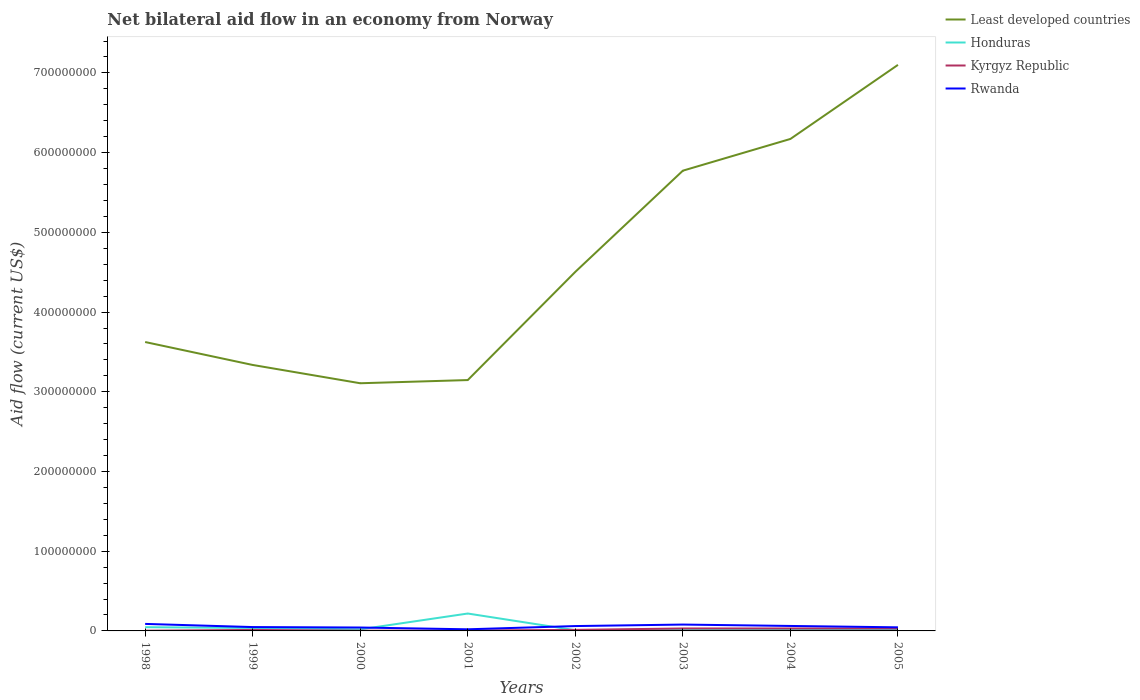Does the line corresponding to Kyrgyz Republic intersect with the line corresponding to Rwanda?
Make the answer very short. No. Is the number of lines equal to the number of legend labels?
Offer a very short reply. Yes. Across all years, what is the maximum net bilateral aid flow in Honduras?
Make the answer very short. 8.80e+05. In which year was the net bilateral aid flow in Honduras maximum?
Your answer should be very brief. 2002. What is the total net bilateral aid flow in Least developed countries in the graph?
Offer a very short reply. -4.00e+06. What is the difference between the highest and the second highest net bilateral aid flow in Honduras?
Offer a terse response. 2.10e+07. What is the difference between the highest and the lowest net bilateral aid flow in Honduras?
Make the answer very short. 1. How many lines are there?
Give a very brief answer. 4. Does the graph contain grids?
Offer a very short reply. No. Where does the legend appear in the graph?
Offer a terse response. Top right. What is the title of the graph?
Offer a terse response. Net bilateral aid flow in an economy from Norway. Does "Mexico" appear as one of the legend labels in the graph?
Your answer should be compact. No. What is the Aid flow (current US$) in Least developed countries in 1998?
Offer a terse response. 3.62e+08. What is the Aid flow (current US$) in Honduras in 1998?
Offer a very short reply. 4.66e+06. What is the Aid flow (current US$) of Kyrgyz Republic in 1998?
Offer a terse response. 3.00e+05. What is the Aid flow (current US$) in Rwanda in 1998?
Your answer should be very brief. 8.80e+06. What is the Aid flow (current US$) in Least developed countries in 1999?
Your answer should be very brief. 3.34e+08. What is the Aid flow (current US$) in Honduras in 1999?
Keep it short and to the point. 3.70e+06. What is the Aid flow (current US$) of Kyrgyz Republic in 1999?
Ensure brevity in your answer.  1.23e+06. What is the Aid flow (current US$) of Rwanda in 1999?
Your answer should be very brief. 4.84e+06. What is the Aid flow (current US$) of Least developed countries in 2000?
Offer a terse response. 3.11e+08. What is the Aid flow (current US$) of Honduras in 2000?
Your response must be concise. 1.97e+06. What is the Aid flow (current US$) in Kyrgyz Republic in 2000?
Offer a very short reply. 2.90e+05. What is the Aid flow (current US$) in Rwanda in 2000?
Your answer should be compact. 4.27e+06. What is the Aid flow (current US$) of Least developed countries in 2001?
Keep it short and to the point. 3.15e+08. What is the Aid flow (current US$) in Honduras in 2001?
Provide a succinct answer. 2.18e+07. What is the Aid flow (current US$) of Kyrgyz Republic in 2001?
Offer a very short reply. 5.10e+05. What is the Aid flow (current US$) of Rwanda in 2001?
Your answer should be very brief. 2.03e+06. What is the Aid flow (current US$) in Least developed countries in 2002?
Keep it short and to the point. 4.50e+08. What is the Aid flow (current US$) of Honduras in 2002?
Make the answer very short. 8.80e+05. What is the Aid flow (current US$) in Kyrgyz Republic in 2002?
Make the answer very short. 1.31e+06. What is the Aid flow (current US$) in Rwanda in 2002?
Provide a succinct answer. 6.09e+06. What is the Aid flow (current US$) of Least developed countries in 2003?
Your answer should be very brief. 5.77e+08. What is the Aid flow (current US$) in Honduras in 2003?
Your response must be concise. 1.63e+06. What is the Aid flow (current US$) in Kyrgyz Republic in 2003?
Ensure brevity in your answer.  3.07e+06. What is the Aid flow (current US$) in Rwanda in 2003?
Provide a short and direct response. 7.97e+06. What is the Aid flow (current US$) of Least developed countries in 2004?
Your answer should be very brief. 6.17e+08. What is the Aid flow (current US$) of Honduras in 2004?
Offer a very short reply. 1.84e+06. What is the Aid flow (current US$) of Kyrgyz Republic in 2004?
Make the answer very short. 3.07e+06. What is the Aid flow (current US$) of Rwanda in 2004?
Provide a succinct answer. 6.24e+06. What is the Aid flow (current US$) in Least developed countries in 2005?
Your answer should be compact. 7.10e+08. What is the Aid flow (current US$) in Honduras in 2005?
Provide a short and direct response. 1.69e+06. What is the Aid flow (current US$) in Kyrgyz Republic in 2005?
Offer a very short reply. 3.08e+06. What is the Aid flow (current US$) in Rwanda in 2005?
Provide a succinct answer. 4.50e+06. Across all years, what is the maximum Aid flow (current US$) in Least developed countries?
Your response must be concise. 7.10e+08. Across all years, what is the maximum Aid flow (current US$) in Honduras?
Provide a succinct answer. 2.18e+07. Across all years, what is the maximum Aid flow (current US$) in Kyrgyz Republic?
Ensure brevity in your answer.  3.08e+06. Across all years, what is the maximum Aid flow (current US$) of Rwanda?
Offer a very short reply. 8.80e+06. Across all years, what is the minimum Aid flow (current US$) in Least developed countries?
Provide a succinct answer. 3.11e+08. Across all years, what is the minimum Aid flow (current US$) of Honduras?
Give a very brief answer. 8.80e+05. Across all years, what is the minimum Aid flow (current US$) in Kyrgyz Republic?
Give a very brief answer. 2.90e+05. Across all years, what is the minimum Aid flow (current US$) in Rwanda?
Keep it short and to the point. 2.03e+06. What is the total Aid flow (current US$) in Least developed countries in the graph?
Offer a terse response. 3.68e+09. What is the total Aid flow (current US$) of Honduras in the graph?
Keep it short and to the point. 3.82e+07. What is the total Aid flow (current US$) in Kyrgyz Republic in the graph?
Give a very brief answer. 1.29e+07. What is the total Aid flow (current US$) of Rwanda in the graph?
Offer a very short reply. 4.47e+07. What is the difference between the Aid flow (current US$) in Least developed countries in 1998 and that in 1999?
Keep it short and to the point. 2.88e+07. What is the difference between the Aid flow (current US$) in Honduras in 1998 and that in 1999?
Offer a terse response. 9.60e+05. What is the difference between the Aid flow (current US$) in Kyrgyz Republic in 1998 and that in 1999?
Your answer should be very brief. -9.30e+05. What is the difference between the Aid flow (current US$) of Rwanda in 1998 and that in 1999?
Make the answer very short. 3.96e+06. What is the difference between the Aid flow (current US$) of Least developed countries in 1998 and that in 2000?
Provide a short and direct response. 5.17e+07. What is the difference between the Aid flow (current US$) of Honduras in 1998 and that in 2000?
Make the answer very short. 2.69e+06. What is the difference between the Aid flow (current US$) of Kyrgyz Republic in 1998 and that in 2000?
Your response must be concise. 10000. What is the difference between the Aid flow (current US$) of Rwanda in 1998 and that in 2000?
Provide a short and direct response. 4.53e+06. What is the difference between the Aid flow (current US$) of Least developed countries in 1998 and that in 2001?
Your answer should be compact. 4.77e+07. What is the difference between the Aid flow (current US$) in Honduras in 1998 and that in 2001?
Give a very brief answer. -1.72e+07. What is the difference between the Aid flow (current US$) of Rwanda in 1998 and that in 2001?
Your answer should be very brief. 6.77e+06. What is the difference between the Aid flow (current US$) in Least developed countries in 1998 and that in 2002?
Your answer should be compact. -8.80e+07. What is the difference between the Aid flow (current US$) in Honduras in 1998 and that in 2002?
Offer a terse response. 3.78e+06. What is the difference between the Aid flow (current US$) of Kyrgyz Republic in 1998 and that in 2002?
Offer a very short reply. -1.01e+06. What is the difference between the Aid flow (current US$) of Rwanda in 1998 and that in 2002?
Your answer should be compact. 2.71e+06. What is the difference between the Aid flow (current US$) in Least developed countries in 1998 and that in 2003?
Make the answer very short. -2.15e+08. What is the difference between the Aid flow (current US$) of Honduras in 1998 and that in 2003?
Offer a very short reply. 3.03e+06. What is the difference between the Aid flow (current US$) in Kyrgyz Republic in 1998 and that in 2003?
Provide a short and direct response. -2.77e+06. What is the difference between the Aid flow (current US$) of Rwanda in 1998 and that in 2003?
Your answer should be very brief. 8.30e+05. What is the difference between the Aid flow (current US$) in Least developed countries in 1998 and that in 2004?
Give a very brief answer. -2.55e+08. What is the difference between the Aid flow (current US$) in Honduras in 1998 and that in 2004?
Offer a terse response. 2.82e+06. What is the difference between the Aid flow (current US$) in Kyrgyz Republic in 1998 and that in 2004?
Ensure brevity in your answer.  -2.77e+06. What is the difference between the Aid flow (current US$) in Rwanda in 1998 and that in 2004?
Give a very brief answer. 2.56e+06. What is the difference between the Aid flow (current US$) of Least developed countries in 1998 and that in 2005?
Make the answer very short. -3.48e+08. What is the difference between the Aid flow (current US$) in Honduras in 1998 and that in 2005?
Provide a short and direct response. 2.97e+06. What is the difference between the Aid flow (current US$) in Kyrgyz Republic in 1998 and that in 2005?
Offer a terse response. -2.78e+06. What is the difference between the Aid flow (current US$) of Rwanda in 1998 and that in 2005?
Your answer should be compact. 4.30e+06. What is the difference between the Aid flow (current US$) in Least developed countries in 1999 and that in 2000?
Provide a succinct answer. 2.30e+07. What is the difference between the Aid flow (current US$) in Honduras in 1999 and that in 2000?
Offer a terse response. 1.73e+06. What is the difference between the Aid flow (current US$) in Kyrgyz Republic in 1999 and that in 2000?
Your answer should be very brief. 9.40e+05. What is the difference between the Aid flow (current US$) of Rwanda in 1999 and that in 2000?
Make the answer very short. 5.70e+05. What is the difference between the Aid flow (current US$) in Least developed countries in 1999 and that in 2001?
Make the answer very short. 1.90e+07. What is the difference between the Aid flow (current US$) of Honduras in 1999 and that in 2001?
Offer a terse response. -1.81e+07. What is the difference between the Aid flow (current US$) of Kyrgyz Republic in 1999 and that in 2001?
Provide a succinct answer. 7.20e+05. What is the difference between the Aid flow (current US$) in Rwanda in 1999 and that in 2001?
Ensure brevity in your answer.  2.81e+06. What is the difference between the Aid flow (current US$) in Least developed countries in 1999 and that in 2002?
Make the answer very short. -1.17e+08. What is the difference between the Aid flow (current US$) of Honduras in 1999 and that in 2002?
Provide a short and direct response. 2.82e+06. What is the difference between the Aid flow (current US$) of Kyrgyz Republic in 1999 and that in 2002?
Provide a succinct answer. -8.00e+04. What is the difference between the Aid flow (current US$) of Rwanda in 1999 and that in 2002?
Provide a succinct answer. -1.25e+06. What is the difference between the Aid flow (current US$) of Least developed countries in 1999 and that in 2003?
Your answer should be compact. -2.44e+08. What is the difference between the Aid flow (current US$) of Honduras in 1999 and that in 2003?
Your answer should be compact. 2.07e+06. What is the difference between the Aid flow (current US$) of Kyrgyz Republic in 1999 and that in 2003?
Keep it short and to the point. -1.84e+06. What is the difference between the Aid flow (current US$) in Rwanda in 1999 and that in 2003?
Your answer should be compact. -3.13e+06. What is the difference between the Aid flow (current US$) of Least developed countries in 1999 and that in 2004?
Provide a short and direct response. -2.84e+08. What is the difference between the Aid flow (current US$) in Honduras in 1999 and that in 2004?
Your answer should be very brief. 1.86e+06. What is the difference between the Aid flow (current US$) of Kyrgyz Republic in 1999 and that in 2004?
Your answer should be compact. -1.84e+06. What is the difference between the Aid flow (current US$) of Rwanda in 1999 and that in 2004?
Make the answer very short. -1.40e+06. What is the difference between the Aid flow (current US$) of Least developed countries in 1999 and that in 2005?
Provide a succinct answer. -3.76e+08. What is the difference between the Aid flow (current US$) in Honduras in 1999 and that in 2005?
Offer a very short reply. 2.01e+06. What is the difference between the Aid flow (current US$) in Kyrgyz Republic in 1999 and that in 2005?
Your answer should be very brief. -1.85e+06. What is the difference between the Aid flow (current US$) of Honduras in 2000 and that in 2001?
Your response must be concise. -1.99e+07. What is the difference between the Aid flow (current US$) in Rwanda in 2000 and that in 2001?
Your answer should be very brief. 2.24e+06. What is the difference between the Aid flow (current US$) of Least developed countries in 2000 and that in 2002?
Your answer should be compact. -1.40e+08. What is the difference between the Aid flow (current US$) of Honduras in 2000 and that in 2002?
Provide a short and direct response. 1.09e+06. What is the difference between the Aid flow (current US$) in Kyrgyz Republic in 2000 and that in 2002?
Provide a short and direct response. -1.02e+06. What is the difference between the Aid flow (current US$) of Rwanda in 2000 and that in 2002?
Provide a succinct answer. -1.82e+06. What is the difference between the Aid flow (current US$) of Least developed countries in 2000 and that in 2003?
Give a very brief answer. -2.67e+08. What is the difference between the Aid flow (current US$) in Kyrgyz Republic in 2000 and that in 2003?
Your response must be concise. -2.78e+06. What is the difference between the Aid flow (current US$) of Rwanda in 2000 and that in 2003?
Offer a very short reply. -3.70e+06. What is the difference between the Aid flow (current US$) of Least developed countries in 2000 and that in 2004?
Provide a succinct answer. -3.06e+08. What is the difference between the Aid flow (current US$) in Kyrgyz Republic in 2000 and that in 2004?
Your answer should be compact. -2.78e+06. What is the difference between the Aid flow (current US$) in Rwanda in 2000 and that in 2004?
Offer a very short reply. -1.97e+06. What is the difference between the Aid flow (current US$) in Least developed countries in 2000 and that in 2005?
Your response must be concise. -3.99e+08. What is the difference between the Aid flow (current US$) of Honduras in 2000 and that in 2005?
Make the answer very short. 2.80e+05. What is the difference between the Aid flow (current US$) of Kyrgyz Republic in 2000 and that in 2005?
Make the answer very short. -2.79e+06. What is the difference between the Aid flow (current US$) in Least developed countries in 2001 and that in 2002?
Offer a terse response. -1.36e+08. What is the difference between the Aid flow (current US$) in Honduras in 2001 and that in 2002?
Your answer should be very brief. 2.10e+07. What is the difference between the Aid flow (current US$) of Kyrgyz Republic in 2001 and that in 2002?
Keep it short and to the point. -8.00e+05. What is the difference between the Aid flow (current US$) in Rwanda in 2001 and that in 2002?
Give a very brief answer. -4.06e+06. What is the difference between the Aid flow (current US$) of Least developed countries in 2001 and that in 2003?
Give a very brief answer. -2.63e+08. What is the difference between the Aid flow (current US$) of Honduras in 2001 and that in 2003?
Ensure brevity in your answer.  2.02e+07. What is the difference between the Aid flow (current US$) of Kyrgyz Republic in 2001 and that in 2003?
Provide a succinct answer. -2.56e+06. What is the difference between the Aid flow (current US$) in Rwanda in 2001 and that in 2003?
Provide a short and direct response. -5.94e+06. What is the difference between the Aid flow (current US$) in Least developed countries in 2001 and that in 2004?
Ensure brevity in your answer.  -3.02e+08. What is the difference between the Aid flow (current US$) in Honduras in 2001 and that in 2004?
Provide a succinct answer. 2.00e+07. What is the difference between the Aid flow (current US$) in Kyrgyz Republic in 2001 and that in 2004?
Your response must be concise. -2.56e+06. What is the difference between the Aid flow (current US$) of Rwanda in 2001 and that in 2004?
Your answer should be compact. -4.21e+06. What is the difference between the Aid flow (current US$) of Least developed countries in 2001 and that in 2005?
Your answer should be very brief. -3.95e+08. What is the difference between the Aid flow (current US$) in Honduras in 2001 and that in 2005?
Provide a short and direct response. 2.01e+07. What is the difference between the Aid flow (current US$) of Kyrgyz Republic in 2001 and that in 2005?
Ensure brevity in your answer.  -2.57e+06. What is the difference between the Aid flow (current US$) of Rwanda in 2001 and that in 2005?
Your answer should be compact. -2.47e+06. What is the difference between the Aid flow (current US$) of Least developed countries in 2002 and that in 2003?
Your answer should be compact. -1.27e+08. What is the difference between the Aid flow (current US$) in Honduras in 2002 and that in 2003?
Keep it short and to the point. -7.50e+05. What is the difference between the Aid flow (current US$) of Kyrgyz Republic in 2002 and that in 2003?
Keep it short and to the point. -1.76e+06. What is the difference between the Aid flow (current US$) of Rwanda in 2002 and that in 2003?
Your answer should be compact. -1.88e+06. What is the difference between the Aid flow (current US$) in Least developed countries in 2002 and that in 2004?
Make the answer very short. -1.67e+08. What is the difference between the Aid flow (current US$) of Honduras in 2002 and that in 2004?
Keep it short and to the point. -9.60e+05. What is the difference between the Aid flow (current US$) of Kyrgyz Republic in 2002 and that in 2004?
Make the answer very short. -1.76e+06. What is the difference between the Aid flow (current US$) of Least developed countries in 2002 and that in 2005?
Your answer should be very brief. -2.60e+08. What is the difference between the Aid flow (current US$) of Honduras in 2002 and that in 2005?
Ensure brevity in your answer.  -8.10e+05. What is the difference between the Aid flow (current US$) of Kyrgyz Republic in 2002 and that in 2005?
Your response must be concise. -1.77e+06. What is the difference between the Aid flow (current US$) of Rwanda in 2002 and that in 2005?
Your answer should be very brief. 1.59e+06. What is the difference between the Aid flow (current US$) in Least developed countries in 2003 and that in 2004?
Offer a very short reply. -3.98e+07. What is the difference between the Aid flow (current US$) in Kyrgyz Republic in 2003 and that in 2004?
Provide a succinct answer. 0. What is the difference between the Aid flow (current US$) of Rwanda in 2003 and that in 2004?
Provide a succinct answer. 1.73e+06. What is the difference between the Aid flow (current US$) in Least developed countries in 2003 and that in 2005?
Your response must be concise. -1.33e+08. What is the difference between the Aid flow (current US$) in Kyrgyz Republic in 2003 and that in 2005?
Provide a short and direct response. -10000. What is the difference between the Aid flow (current US$) of Rwanda in 2003 and that in 2005?
Ensure brevity in your answer.  3.47e+06. What is the difference between the Aid flow (current US$) in Least developed countries in 2004 and that in 2005?
Your answer should be compact. -9.29e+07. What is the difference between the Aid flow (current US$) of Kyrgyz Republic in 2004 and that in 2005?
Provide a short and direct response. -10000. What is the difference between the Aid flow (current US$) in Rwanda in 2004 and that in 2005?
Make the answer very short. 1.74e+06. What is the difference between the Aid flow (current US$) of Least developed countries in 1998 and the Aid flow (current US$) of Honduras in 1999?
Keep it short and to the point. 3.59e+08. What is the difference between the Aid flow (current US$) in Least developed countries in 1998 and the Aid flow (current US$) in Kyrgyz Republic in 1999?
Your answer should be very brief. 3.61e+08. What is the difference between the Aid flow (current US$) of Least developed countries in 1998 and the Aid flow (current US$) of Rwanda in 1999?
Offer a very short reply. 3.58e+08. What is the difference between the Aid flow (current US$) in Honduras in 1998 and the Aid flow (current US$) in Kyrgyz Republic in 1999?
Offer a terse response. 3.43e+06. What is the difference between the Aid flow (current US$) of Kyrgyz Republic in 1998 and the Aid flow (current US$) of Rwanda in 1999?
Offer a very short reply. -4.54e+06. What is the difference between the Aid flow (current US$) of Least developed countries in 1998 and the Aid flow (current US$) of Honduras in 2000?
Provide a succinct answer. 3.60e+08. What is the difference between the Aid flow (current US$) of Least developed countries in 1998 and the Aid flow (current US$) of Kyrgyz Republic in 2000?
Your answer should be compact. 3.62e+08. What is the difference between the Aid flow (current US$) of Least developed countries in 1998 and the Aid flow (current US$) of Rwanda in 2000?
Ensure brevity in your answer.  3.58e+08. What is the difference between the Aid flow (current US$) in Honduras in 1998 and the Aid flow (current US$) in Kyrgyz Republic in 2000?
Keep it short and to the point. 4.37e+06. What is the difference between the Aid flow (current US$) of Kyrgyz Republic in 1998 and the Aid flow (current US$) of Rwanda in 2000?
Your answer should be very brief. -3.97e+06. What is the difference between the Aid flow (current US$) in Least developed countries in 1998 and the Aid flow (current US$) in Honduras in 2001?
Your answer should be very brief. 3.41e+08. What is the difference between the Aid flow (current US$) of Least developed countries in 1998 and the Aid flow (current US$) of Kyrgyz Republic in 2001?
Offer a terse response. 3.62e+08. What is the difference between the Aid flow (current US$) in Least developed countries in 1998 and the Aid flow (current US$) in Rwanda in 2001?
Ensure brevity in your answer.  3.60e+08. What is the difference between the Aid flow (current US$) in Honduras in 1998 and the Aid flow (current US$) in Kyrgyz Republic in 2001?
Your answer should be compact. 4.15e+06. What is the difference between the Aid flow (current US$) in Honduras in 1998 and the Aid flow (current US$) in Rwanda in 2001?
Your answer should be very brief. 2.63e+06. What is the difference between the Aid flow (current US$) of Kyrgyz Republic in 1998 and the Aid flow (current US$) of Rwanda in 2001?
Ensure brevity in your answer.  -1.73e+06. What is the difference between the Aid flow (current US$) in Least developed countries in 1998 and the Aid flow (current US$) in Honduras in 2002?
Your response must be concise. 3.62e+08. What is the difference between the Aid flow (current US$) of Least developed countries in 1998 and the Aid flow (current US$) of Kyrgyz Republic in 2002?
Your answer should be very brief. 3.61e+08. What is the difference between the Aid flow (current US$) of Least developed countries in 1998 and the Aid flow (current US$) of Rwanda in 2002?
Ensure brevity in your answer.  3.56e+08. What is the difference between the Aid flow (current US$) of Honduras in 1998 and the Aid flow (current US$) of Kyrgyz Republic in 2002?
Your response must be concise. 3.35e+06. What is the difference between the Aid flow (current US$) of Honduras in 1998 and the Aid flow (current US$) of Rwanda in 2002?
Provide a succinct answer. -1.43e+06. What is the difference between the Aid flow (current US$) in Kyrgyz Republic in 1998 and the Aid flow (current US$) in Rwanda in 2002?
Offer a very short reply. -5.79e+06. What is the difference between the Aid flow (current US$) in Least developed countries in 1998 and the Aid flow (current US$) in Honduras in 2003?
Your answer should be compact. 3.61e+08. What is the difference between the Aid flow (current US$) in Least developed countries in 1998 and the Aid flow (current US$) in Kyrgyz Republic in 2003?
Keep it short and to the point. 3.59e+08. What is the difference between the Aid flow (current US$) of Least developed countries in 1998 and the Aid flow (current US$) of Rwanda in 2003?
Your answer should be compact. 3.54e+08. What is the difference between the Aid flow (current US$) in Honduras in 1998 and the Aid flow (current US$) in Kyrgyz Republic in 2003?
Your response must be concise. 1.59e+06. What is the difference between the Aid flow (current US$) of Honduras in 1998 and the Aid flow (current US$) of Rwanda in 2003?
Your answer should be compact. -3.31e+06. What is the difference between the Aid flow (current US$) of Kyrgyz Republic in 1998 and the Aid flow (current US$) of Rwanda in 2003?
Keep it short and to the point. -7.67e+06. What is the difference between the Aid flow (current US$) in Least developed countries in 1998 and the Aid flow (current US$) in Honduras in 2004?
Ensure brevity in your answer.  3.61e+08. What is the difference between the Aid flow (current US$) in Least developed countries in 1998 and the Aid flow (current US$) in Kyrgyz Republic in 2004?
Your response must be concise. 3.59e+08. What is the difference between the Aid flow (current US$) of Least developed countries in 1998 and the Aid flow (current US$) of Rwanda in 2004?
Keep it short and to the point. 3.56e+08. What is the difference between the Aid flow (current US$) of Honduras in 1998 and the Aid flow (current US$) of Kyrgyz Republic in 2004?
Give a very brief answer. 1.59e+06. What is the difference between the Aid flow (current US$) of Honduras in 1998 and the Aid flow (current US$) of Rwanda in 2004?
Offer a very short reply. -1.58e+06. What is the difference between the Aid flow (current US$) of Kyrgyz Republic in 1998 and the Aid flow (current US$) of Rwanda in 2004?
Make the answer very short. -5.94e+06. What is the difference between the Aid flow (current US$) in Least developed countries in 1998 and the Aid flow (current US$) in Honduras in 2005?
Offer a very short reply. 3.61e+08. What is the difference between the Aid flow (current US$) of Least developed countries in 1998 and the Aid flow (current US$) of Kyrgyz Republic in 2005?
Your response must be concise. 3.59e+08. What is the difference between the Aid flow (current US$) of Least developed countries in 1998 and the Aid flow (current US$) of Rwanda in 2005?
Make the answer very short. 3.58e+08. What is the difference between the Aid flow (current US$) of Honduras in 1998 and the Aid flow (current US$) of Kyrgyz Republic in 2005?
Your answer should be very brief. 1.58e+06. What is the difference between the Aid flow (current US$) of Honduras in 1998 and the Aid flow (current US$) of Rwanda in 2005?
Provide a short and direct response. 1.60e+05. What is the difference between the Aid flow (current US$) in Kyrgyz Republic in 1998 and the Aid flow (current US$) in Rwanda in 2005?
Your response must be concise. -4.20e+06. What is the difference between the Aid flow (current US$) of Least developed countries in 1999 and the Aid flow (current US$) of Honduras in 2000?
Offer a very short reply. 3.32e+08. What is the difference between the Aid flow (current US$) of Least developed countries in 1999 and the Aid flow (current US$) of Kyrgyz Republic in 2000?
Your response must be concise. 3.33e+08. What is the difference between the Aid flow (current US$) of Least developed countries in 1999 and the Aid flow (current US$) of Rwanda in 2000?
Make the answer very short. 3.29e+08. What is the difference between the Aid flow (current US$) in Honduras in 1999 and the Aid flow (current US$) in Kyrgyz Republic in 2000?
Provide a succinct answer. 3.41e+06. What is the difference between the Aid flow (current US$) in Honduras in 1999 and the Aid flow (current US$) in Rwanda in 2000?
Provide a succinct answer. -5.70e+05. What is the difference between the Aid flow (current US$) in Kyrgyz Republic in 1999 and the Aid flow (current US$) in Rwanda in 2000?
Ensure brevity in your answer.  -3.04e+06. What is the difference between the Aid flow (current US$) of Least developed countries in 1999 and the Aid flow (current US$) of Honduras in 2001?
Offer a very short reply. 3.12e+08. What is the difference between the Aid flow (current US$) of Least developed countries in 1999 and the Aid flow (current US$) of Kyrgyz Republic in 2001?
Your answer should be compact. 3.33e+08. What is the difference between the Aid flow (current US$) in Least developed countries in 1999 and the Aid flow (current US$) in Rwanda in 2001?
Ensure brevity in your answer.  3.32e+08. What is the difference between the Aid flow (current US$) of Honduras in 1999 and the Aid flow (current US$) of Kyrgyz Republic in 2001?
Your answer should be very brief. 3.19e+06. What is the difference between the Aid flow (current US$) of Honduras in 1999 and the Aid flow (current US$) of Rwanda in 2001?
Offer a terse response. 1.67e+06. What is the difference between the Aid flow (current US$) of Kyrgyz Republic in 1999 and the Aid flow (current US$) of Rwanda in 2001?
Ensure brevity in your answer.  -8.00e+05. What is the difference between the Aid flow (current US$) of Least developed countries in 1999 and the Aid flow (current US$) of Honduras in 2002?
Offer a very short reply. 3.33e+08. What is the difference between the Aid flow (current US$) in Least developed countries in 1999 and the Aid flow (current US$) in Kyrgyz Republic in 2002?
Make the answer very short. 3.32e+08. What is the difference between the Aid flow (current US$) of Least developed countries in 1999 and the Aid flow (current US$) of Rwanda in 2002?
Your answer should be very brief. 3.28e+08. What is the difference between the Aid flow (current US$) of Honduras in 1999 and the Aid flow (current US$) of Kyrgyz Republic in 2002?
Your answer should be very brief. 2.39e+06. What is the difference between the Aid flow (current US$) in Honduras in 1999 and the Aid flow (current US$) in Rwanda in 2002?
Your answer should be compact. -2.39e+06. What is the difference between the Aid flow (current US$) of Kyrgyz Republic in 1999 and the Aid flow (current US$) of Rwanda in 2002?
Provide a short and direct response. -4.86e+06. What is the difference between the Aid flow (current US$) of Least developed countries in 1999 and the Aid flow (current US$) of Honduras in 2003?
Keep it short and to the point. 3.32e+08. What is the difference between the Aid flow (current US$) in Least developed countries in 1999 and the Aid flow (current US$) in Kyrgyz Republic in 2003?
Give a very brief answer. 3.31e+08. What is the difference between the Aid flow (current US$) in Least developed countries in 1999 and the Aid flow (current US$) in Rwanda in 2003?
Ensure brevity in your answer.  3.26e+08. What is the difference between the Aid flow (current US$) of Honduras in 1999 and the Aid flow (current US$) of Kyrgyz Republic in 2003?
Offer a terse response. 6.30e+05. What is the difference between the Aid flow (current US$) in Honduras in 1999 and the Aid flow (current US$) in Rwanda in 2003?
Your response must be concise. -4.27e+06. What is the difference between the Aid flow (current US$) in Kyrgyz Republic in 1999 and the Aid flow (current US$) in Rwanda in 2003?
Your answer should be very brief. -6.74e+06. What is the difference between the Aid flow (current US$) in Least developed countries in 1999 and the Aid flow (current US$) in Honduras in 2004?
Give a very brief answer. 3.32e+08. What is the difference between the Aid flow (current US$) of Least developed countries in 1999 and the Aid flow (current US$) of Kyrgyz Republic in 2004?
Give a very brief answer. 3.31e+08. What is the difference between the Aid flow (current US$) in Least developed countries in 1999 and the Aid flow (current US$) in Rwanda in 2004?
Offer a terse response. 3.27e+08. What is the difference between the Aid flow (current US$) of Honduras in 1999 and the Aid flow (current US$) of Kyrgyz Republic in 2004?
Your answer should be very brief. 6.30e+05. What is the difference between the Aid flow (current US$) of Honduras in 1999 and the Aid flow (current US$) of Rwanda in 2004?
Provide a succinct answer. -2.54e+06. What is the difference between the Aid flow (current US$) of Kyrgyz Republic in 1999 and the Aid flow (current US$) of Rwanda in 2004?
Provide a succinct answer. -5.01e+06. What is the difference between the Aid flow (current US$) of Least developed countries in 1999 and the Aid flow (current US$) of Honduras in 2005?
Offer a terse response. 3.32e+08. What is the difference between the Aid flow (current US$) of Least developed countries in 1999 and the Aid flow (current US$) of Kyrgyz Republic in 2005?
Ensure brevity in your answer.  3.31e+08. What is the difference between the Aid flow (current US$) of Least developed countries in 1999 and the Aid flow (current US$) of Rwanda in 2005?
Give a very brief answer. 3.29e+08. What is the difference between the Aid flow (current US$) in Honduras in 1999 and the Aid flow (current US$) in Kyrgyz Republic in 2005?
Your answer should be very brief. 6.20e+05. What is the difference between the Aid flow (current US$) in Honduras in 1999 and the Aid flow (current US$) in Rwanda in 2005?
Give a very brief answer. -8.00e+05. What is the difference between the Aid flow (current US$) of Kyrgyz Republic in 1999 and the Aid flow (current US$) of Rwanda in 2005?
Make the answer very short. -3.27e+06. What is the difference between the Aid flow (current US$) of Least developed countries in 2000 and the Aid flow (current US$) of Honduras in 2001?
Your response must be concise. 2.89e+08. What is the difference between the Aid flow (current US$) in Least developed countries in 2000 and the Aid flow (current US$) in Kyrgyz Republic in 2001?
Make the answer very short. 3.10e+08. What is the difference between the Aid flow (current US$) in Least developed countries in 2000 and the Aid flow (current US$) in Rwanda in 2001?
Make the answer very short. 3.09e+08. What is the difference between the Aid flow (current US$) in Honduras in 2000 and the Aid flow (current US$) in Kyrgyz Republic in 2001?
Ensure brevity in your answer.  1.46e+06. What is the difference between the Aid flow (current US$) in Kyrgyz Republic in 2000 and the Aid flow (current US$) in Rwanda in 2001?
Give a very brief answer. -1.74e+06. What is the difference between the Aid flow (current US$) in Least developed countries in 2000 and the Aid flow (current US$) in Honduras in 2002?
Keep it short and to the point. 3.10e+08. What is the difference between the Aid flow (current US$) of Least developed countries in 2000 and the Aid flow (current US$) of Kyrgyz Republic in 2002?
Keep it short and to the point. 3.09e+08. What is the difference between the Aid flow (current US$) in Least developed countries in 2000 and the Aid flow (current US$) in Rwanda in 2002?
Keep it short and to the point. 3.05e+08. What is the difference between the Aid flow (current US$) in Honduras in 2000 and the Aid flow (current US$) in Rwanda in 2002?
Offer a very short reply. -4.12e+06. What is the difference between the Aid flow (current US$) in Kyrgyz Republic in 2000 and the Aid flow (current US$) in Rwanda in 2002?
Make the answer very short. -5.80e+06. What is the difference between the Aid flow (current US$) in Least developed countries in 2000 and the Aid flow (current US$) in Honduras in 2003?
Provide a short and direct response. 3.09e+08. What is the difference between the Aid flow (current US$) in Least developed countries in 2000 and the Aid flow (current US$) in Kyrgyz Republic in 2003?
Keep it short and to the point. 3.08e+08. What is the difference between the Aid flow (current US$) of Least developed countries in 2000 and the Aid flow (current US$) of Rwanda in 2003?
Make the answer very short. 3.03e+08. What is the difference between the Aid flow (current US$) in Honduras in 2000 and the Aid flow (current US$) in Kyrgyz Republic in 2003?
Give a very brief answer. -1.10e+06. What is the difference between the Aid flow (current US$) in Honduras in 2000 and the Aid flow (current US$) in Rwanda in 2003?
Make the answer very short. -6.00e+06. What is the difference between the Aid flow (current US$) of Kyrgyz Republic in 2000 and the Aid flow (current US$) of Rwanda in 2003?
Your answer should be compact. -7.68e+06. What is the difference between the Aid flow (current US$) in Least developed countries in 2000 and the Aid flow (current US$) in Honduras in 2004?
Give a very brief answer. 3.09e+08. What is the difference between the Aid flow (current US$) of Least developed countries in 2000 and the Aid flow (current US$) of Kyrgyz Republic in 2004?
Your response must be concise. 3.08e+08. What is the difference between the Aid flow (current US$) in Least developed countries in 2000 and the Aid flow (current US$) in Rwanda in 2004?
Give a very brief answer. 3.04e+08. What is the difference between the Aid flow (current US$) of Honduras in 2000 and the Aid flow (current US$) of Kyrgyz Republic in 2004?
Your answer should be very brief. -1.10e+06. What is the difference between the Aid flow (current US$) in Honduras in 2000 and the Aid flow (current US$) in Rwanda in 2004?
Provide a succinct answer. -4.27e+06. What is the difference between the Aid flow (current US$) in Kyrgyz Republic in 2000 and the Aid flow (current US$) in Rwanda in 2004?
Ensure brevity in your answer.  -5.95e+06. What is the difference between the Aid flow (current US$) in Least developed countries in 2000 and the Aid flow (current US$) in Honduras in 2005?
Your response must be concise. 3.09e+08. What is the difference between the Aid flow (current US$) in Least developed countries in 2000 and the Aid flow (current US$) in Kyrgyz Republic in 2005?
Provide a short and direct response. 3.08e+08. What is the difference between the Aid flow (current US$) of Least developed countries in 2000 and the Aid flow (current US$) of Rwanda in 2005?
Keep it short and to the point. 3.06e+08. What is the difference between the Aid flow (current US$) of Honduras in 2000 and the Aid flow (current US$) of Kyrgyz Republic in 2005?
Provide a succinct answer. -1.11e+06. What is the difference between the Aid flow (current US$) of Honduras in 2000 and the Aid flow (current US$) of Rwanda in 2005?
Provide a short and direct response. -2.53e+06. What is the difference between the Aid flow (current US$) of Kyrgyz Republic in 2000 and the Aid flow (current US$) of Rwanda in 2005?
Provide a short and direct response. -4.21e+06. What is the difference between the Aid flow (current US$) in Least developed countries in 2001 and the Aid flow (current US$) in Honduras in 2002?
Keep it short and to the point. 3.14e+08. What is the difference between the Aid flow (current US$) of Least developed countries in 2001 and the Aid flow (current US$) of Kyrgyz Republic in 2002?
Offer a terse response. 3.13e+08. What is the difference between the Aid flow (current US$) of Least developed countries in 2001 and the Aid flow (current US$) of Rwanda in 2002?
Provide a short and direct response. 3.09e+08. What is the difference between the Aid flow (current US$) of Honduras in 2001 and the Aid flow (current US$) of Kyrgyz Republic in 2002?
Your response must be concise. 2.05e+07. What is the difference between the Aid flow (current US$) of Honduras in 2001 and the Aid flow (current US$) of Rwanda in 2002?
Your response must be concise. 1.57e+07. What is the difference between the Aid flow (current US$) of Kyrgyz Republic in 2001 and the Aid flow (current US$) of Rwanda in 2002?
Your response must be concise. -5.58e+06. What is the difference between the Aid flow (current US$) of Least developed countries in 2001 and the Aid flow (current US$) of Honduras in 2003?
Keep it short and to the point. 3.13e+08. What is the difference between the Aid flow (current US$) of Least developed countries in 2001 and the Aid flow (current US$) of Kyrgyz Republic in 2003?
Your answer should be compact. 3.12e+08. What is the difference between the Aid flow (current US$) of Least developed countries in 2001 and the Aid flow (current US$) of Rwanda in 2003?
Your answer should be compact. 3.07e+08. What is the difference between the Aid flow (current US$) of Honduras in 2001 and the Aid flow (current US$) of Kyrgyz Republic in 2003?
Your answer should be compact. 1.88e+07. What is the difference between the Aid flow (current US$) in Honduras in 2001 and the Aid flow (current US$) in Rwanda in 2003?
Keep it short and to the point. 1.39e+07. What is the difference between the Aid flow (current US$) of Kyrgyz Republic in 2001 and the Aid flow (current US$) of Rwanda in 2003?
Your answer should be compact. -7.46e+06. What is the difference between the Aid flow (current US$) in Least developed countries in 2001 and the Aid flow (current US$) in Honduras in 2004?
Offer a terse response. 3.13e+08. What is the difference between the Aid flow (current US$) in Least developed countries in 2001 and the Aid flow (current US$) in Kyrgyz Republic in 2004?
Provide a succinct answer. 3.12e+08. What is the difference between the Aid flow (current US$) of Least developed countries in 2001 and the Aid flow (current US$) of Rwanda in 2004?
Ensure brevity in your answer.  3.08e+08. What is the difference between the Aid flow (current US$) of Honduras in 2001 and the Aid flow (current US$) of Kyrgyz Republic in 2004?
Ensure brevity in your answer.  1.88e+07. What is the difference between the Aid flow (current US$) in Honduras in 2001 and the Aid flow (current US$) in Rwanda in 2004?
Your answer should be compact. 1.56e+07. What is the difference between the Aid flow (current US$) of Kyrgyz Republic in 2001 and the Aid flow (current US$) of Rwanda in 2004?
Your answer should be very brief. -5.73e+06. What is the difference between the Aid flow (current US$) of Least developed countries in 2001 and the Aid flow (current US$) of Honduras in 2005?
Your response must be concise. 3.13e+08. What is the difference between the Aid flow (current US$) of Least developed countries in 2001 and the Aid flow (current US$) of Kyrgyz Republic in 2005?
Give a very brief answer. 3.12e+08. What is the difference between the Aid flow (current US$) of Least developed countries in 2001 and the Aid flow (current US$) of Rwanda in 2005?
Your answer should be compact. 3.10e+08. What is the difference between the Aid flow (current US$) of Honduras in 2001 and the Aid flow (current US$) of Kyrgyz Republic in 2005?
Keep it short and to the point. 1.88e+07. What is the difference between the Aid flow (current US$) of Honduras in 2001 and the Aid flow (current US$) of Rwanda in 2005?
Your answer should be compact. 1.73e+07. What is the difference between the Aid flow (current US$) of Kyrgyz Republic in 2001 and the Aid flow (current US$) of Rwanda in 2005?
Ensure brevity in your answer.  -3.99e+06. What is the difference between the Aid flow (current US$) in Least developed countries in 2002 and the Aid flow (current US$) in Honduras in 2003?
Provide a succinct answer. 4.49e+08. What is the difference between the Aid flow (current US$) in Least developed countries in 2002 and the Aid flow (current US$) in Kyrgyz Republic in 2003?
Offer a very short reply. 4.47e+08. What is the difference between the Aid flow (current US$) in Least developed countries in 2002 and the Aid flow (current US$) in Rwanda in 2003?
Give a very brief answer. 4.42e+08. What is the difference between the Aid flow (current US$) in Honduras in 2002 and the Aid flow (current US$) in Kyrgyz Republic in 2003?
Provide a succinct answer. -2.19e+06. What is the difference between the Aid flow (current US$) of Honduras in 2002 and the Aid flow (current US$) of Rwanda in 2003?
Give a very brief answer. -7.09e+06. What is the difference between the Aid flow (current US$) in Kyrgyz Republic in 2002 and the Aid flow (current US$) in Rwanda in 2003?
Give a very brief answer. -6.66e+06. What is the difference between the Aid flow (current US$) in Least developed countries in 2002 and the Aid flow (current US$) in Honduras in 2004?
Provide a succinct answer. 4.49e+08. What is the difference between the Aid flow (current US$) in Least developed countries in 2002 and the Aid flow (current US$) in Kyrgyz Republic in 2004?
Provide a short and direct response. 4.47e+08. What is the difference between the Aid flow (current US$) of Least developed countries in 2002 and the Aid flow (current US$) of Rwanda in 2004?
Give a very brief answer. 4.44e+08. What is the difference between the Aid flow (current US$) in Honduras in 2002 and the Aid flow (current US$) in Kyrgyz Republic in 2004?
Keep it short and to the point. -2.19e+06. What is the difference between the Aid flow (current US$) of Honduras in 2002 and the Aid flow (current US$) of Rwanda in 2004?
Make the answer very short. -5.36e+06. What is the difference between the Aid flow (current US$) of Kyrgyz Republic in 2002 and the Aid flow (current US$) of Rwanda in 2004?
Keep it short and to the point. -4.93e+06. What is the difference between the Aid flow (current US$) in Least developed countries in 2002 and the Aid flow (current US$) in Honduras in 2005?
Ensure brevity in your answer.  4.49e+08. What is the difference between the Aid flow (current US$) of Least developed countries in 2002 and the Aid flow (current US$) of Kyrgyz Republic in 2005?
Keep it short and to the point. 4.47e+08. What is the difference between the Aid flow (current US$) in Least developed countries in 2002 and the Aid flow (current US$) in Rwanda in 2005?
Keep it short and to the point. 4.46e+08. What is the difference between the Aid flow (current US$) of Honduras in 2002 and the Aid flow (current US$) of Kyrgyz Republic in 2005?
Offer a terse response. -2.20e+06. What is the difference between the Aid flow (current US$) in Honduras in 2002 and the Aid flow (current US$) in Rwanda in 2005?
Give a very brief answer. -3.62e+06. What is the difference between the Aid flow (current US$) in Kyrgyz Republic in 2002 and the Aid flow (current US$) in Rwanda in 2005?
Your response must be concise. -3.19e+06. What is the difference between the Aid flow (current US$) in Least developed countries in 2003 and the Aid flow (current US$) in Honduras in 2004?
Provide a short and direct response. 5.76e+08. What is the difference between the Aid flow (current US$) of Least developed countries in 2003 and the Aid flow (current US$) of Kyrgyz Republic in 2004?
Your answer should be very brief. 5.74e+08. What is the difference between the Aid flow (current US$) in Least developed countries in 2003 and the Aid flow (current US$) in Rwanda in 2004?
Make the answer very short. 5.71e+08. What is the difference between the Aid flow (current US$) of Honduras in 2003 and the Aid flow (current US$) of Kyrgyz Republic in 2004?
Offer a terse response. -1.44e+06. What is the difference between the Aid flow (current US$) in Honduras in 2003 and the Aid flow (current US$) in Rwanda in 2004?
Ensure brevity in your answer.  -4.61e+06. What is the difference between the Aid flow (current US$) of Kyrgyz Republic in 2003 and the Aid flow (current US$) of Rwanda in 2004?
Give a very brief answer. -3.17e+06. What is the difference between the Aid flow (current US$) in Least developed countries in 2003 and the Aid flow (current US$) in Honduras in 2005?
Offer a terse response. 5.76e+08. What is the difference between the Aid flow (current US$) of Least developed countries in 2003 and the Aid flow (current US$) of Kyrgyz Republic in 2005?
Offer a terse response. 5.74e+08. What is the difference between the Aid flow (current US$) of Least developed countries in 2003 and the Aid flow (current US$) of Rwanda in 2005?
Keep it short and to the point. 5.73e+08. What is the difference between the Aid flow (current US$) of Honduras in 2003 and the Aid flow (current US$) of Kyrgyz Republic in 2005?
Your response must be concise. -1.45e+06. What is the difference between the Aid flow (current US$) of Honduras in 2003 and the Aid flow (current US$) of Rwanda in 2005?
Provide a short and direct response. -2.87e+06. What is the difference between the Aid flow (current US$) in Kyrgyz Republic in 2003 and the Aid flow (current US$) in Rwanda in 2005?
Offer a terse response. -1.43e+06. What is the difference between the Aid flow (current US$) of Least developed countries in 2004 and the Aid flow (current US$) of Honduras in 2005?
Give a very brief answer. 6.16e+08. What is the difference between the Aid flow (current US$) of Least developed countries in 2004 and the Aid flow (current US$) of Kyrgyz Republic in 2005?
Offer a terse response. 6.14e+08. What is the difference between the Aid flow (current US$) of Least developed countries in 2004 and the Aid flow (current US$) of Rwanda in 2005?
Provide a short and direct response. 6.13e+08. What is the difference between the Aid flow (current US$) in Honduras in 2004 and the Aid flow (current US$) in Kyrgyz Republic in 2005?
Keep it short and to the point. -1.24e+06. What is the difference between the Aid flow (current US$) of Honduras in 2004 and the Aid flow (current US$) of Rwanda in 2005?
Ensure brevity in your answer.  -2.66e+06. What is the difference between the Aid flow (current US$) of Kyrgyz Republic in 2004 and the Aid flow (current US$) of Rwanda in 2005?
Offer a terse response. -1.43e+06. What is the average Aid flow (current US$) of Least developed countries per year?
Keep it short and to the point. 4.60e+08. What is the average Aid flow (current US$) of Honduras per year?
Your answer should be very brief. 4.78e+06. What is the average Aid flow (current US$) of Kyrgyz Republic per year?
Provide a succinct answer. 1.61e+06. What is the average Aid flow (current US$) of Rwanda per year?
Your answer should be very brief. 5.59e+06. In the year 1998, what is the difference between the Aid flow (current US$) of Least developed countries and Aid flow (current US$) of Honduras?
Your response must be concise. 3.58e+08. In the year 1998, what is the difference between the Aid flow (current US$) of Least developed countries and Aid flow (current US$) of Kyrgyz Republic?
Give a very brief answer. 3.62e+08. In the year 1998, what is the difference between the Aid flow (current US$) of Least developed countries and Aid flow (current US$) of Rwanda?
Your response must be concise. 3.54e+08. In the year 1998, what is the difference between the Aid flow (current US$) of Honduras and Aid flow (current US$) of Kyrgyz Republic?
Your response must be concise. 4.36e+06. In the year 1998, what is the difference between the Aid flow (current US$) of Honduras and Aid flow (current US$) of Rwanda?
Make the answer very short. -4.14e+06. In the year 1998, what is the difference between the Aid flow (current US$) in Kyrgyz Republic and Aid flow (current US$) in Rwanda?
Offer a terse response. -8.50e+06. In the year 1999, what is the difference between the Aid flow (current US$) in Least developed countries and Aid flow (current US$) in Honduras?
Offer a very short reply. 3.30e+08. In the year 1999, what is the difference between the Aid flow (current US$) of Least developed countries and Aid flow (current US$) of Kyrgyz Republic?
Offer a very short reply. 3.32e+08. In the year 1999, what is the difference between the Aid flow (current US$) in Least developed countries and Aid flow (current US$) in Rwanda?
Provide a succinct answer. 3.29e+08. In the year 1999, what is the difference between the Aid flow (current US$) in Honduras and Aid flow (current US$) in Kyrgyz Republic?
Your answer should be very brief. 2.47e+06. In the year 1999, what is the difference between the Aid flow (current US$) in Honduras and Aid flow (current US$) in Rwanda?
Make the answer very short. -1.14e+06. In the year 1999, what is the difference between the Aid flow (current US$) of Kyrgyz Republic and Aid flow (current US$) of Rwanda?
Provide a short and direct response. -3.61e+06. In the year 2000, what is the difference between the Aid flow (current US$) in Least developed countries and Aid flow (current US$) in Honduras?
Keep it short and to the point. 3.09e+08. In the year 2000, what is the difference between the Aid flow (current US$) in Least developed countries and Aid flow (current US$) in Kyrgyz Republic?
Provide a succinct answer. 3.10e+08. In the year 2000, what is the difference between the Aid flow (current US$) in Least developed countries and Aid flow (current US$) in Rwanda?
Your answer should be very brief. 3.06e+08. In the year 2000, what is the difference between the Aid flow (current US$) in Honduras and Aid flow (current US$) in Kyrgyz Republic?
Provide a short and direct response. 1.68e+06. In the year 2000, what is the difference between the Aid flow (current US$) of Honduras and Aid flow (current US$) of Rwanda?
Your response must be concise. -2.30e+06. In the year 2000, what is the difference between the Aid flow (current US$) of Kyrgyz Republic and Aid flow (current US$) of Rwanda?
Your response must be concise. -3.98e+06. In the year 2001, what is the difference between the Aid flow (current US$) of Least developed countries and Aid flow (current US$) of Honduras?
Offer a very short reply. 2.93e+08. In the year 2001, what is the difference between the Aid flow (current US$) of Least developed countries and Aid flow (current US$) of Kyrgyz Republic?
Ensure brevity in your answer.  3.14e+08. In the year 2001, what is the difference between the Aid flow (current US$) in Least developed countries and Aid flow (current US$) in Rwanda?
Ensure brevity in your answer.  3.13e+08. In the year 2001, what is the difference between the Aid flow (current US$) of Honduras and Aid flow (current US$) of Kyrgyz Republic?
Your answer should be compact. 2.13e+07. In the year 2001, what is the difference between the Aid flow (current US$) of Honduras and Aid flow (current US$) of Rwanda?
Your response must be concise. 1.98e+07. In the year 2001, what is the difference between the Aid flow (current US$) of Kyrgyz Republic and Aid flow (current US$) of Rwanda?
Your answer should be compact. -1.52e+06. In the year 2002, what is the difference between the Aid flow (current US$) of Least developed countries and Aid flow (current US$) of Honduras?
Provide a succinct answer. 4.50e+08. In the year 2002, what is the difference between the Aid flow (current US$) of Least developed countries and Aid flow (current US$) of Kyrgyz Republic?
Make the answer very short. 4.49e+08. In the year 2002, what is the difference between the Aid flow (current US$) in Least developed countries and Aid flow (current US$) in Rwanda?
Your response must be concise. 4.44e+08. In the year 2002, what is the difference between the Aid flow (current US$) of Honduras and Aid flow (current US$) of Kyrgyz Republic?
Make the answer very short. -4.30e+05. In the year 2002, what is the difference between the Aid flow (current US$) of Honduras and Aid flow (current US$) of Rwanda?
Give a very brief answer. -5.21e+06. In the year 2002, what is the difference between the Aid flow (current US$) in Kyrgyz Republic and Aid flow (current US$) in Rwanda?
Keep it short and to the point. -4.78e+06. In the year 2003, what is the difference between the Aid flow (current US$) in Least developed countries and Aid flow (current US$) in Honduras?
Your answer should be very brief. 5.76e+08. In the year 2003, what is the difference between the Aid flow (current US$) in Least developed countries and Aid flow (current US$) in Kyrgyz Republic?
Provide a short and direct response. 5.74e+08. In the year 2003, what is the difference between the Aid flow (current US$) in Least developed countries and Aid flow (current US$) in Rwanda?
Provide a succinct answer. 5.69e+08. In the year 2003, what is the difference between the Aid flow (current US$) in Honduras and Aid flow (current US$) in Kyrgyz Republic?
Your answer should be compact. -1.44e+06. In the year 2003, what is the difference between the Aid flow (current US$) in Honduras and Aid flow (current US$) in Rwanda?
Give a very brief answer. -6.34e+06. In the year 2003, what is the difference between the Aid flow (current US$) of Kyrgyz Republic and Aid flow (current US$) of Rwanda?
Your answer should be very brief. -4.90e+06. In the year 2004, what is the difference between the Aid flow (current US$) in Least developed countries and Aid flow (current US$) in Honduras?
Provide a short and direct response. 6.15e+08. In the year 2004, what is the difference between the Aid flow (current US$) of Least developed countries and Aid flow (current US$) of Kyrgyz Republic?
Keep it short and to the point. 6.14e+08. In the year 2004, what is the difference between the Aid flow (current US$) in Least developed countries and Aid flow (current US$) in Rwanda?
Offer a very short reply. 6.11e+08. In the year 2004, what is the difference between the Aid flow (current US$) in Honduras and Aid flow (current US$) in Kyrgyz Republic?
Provide a short and direct response. -1.23e+06. In the year 2004, what is the difference between the Aid flow (current US$) in Honduras and Aid flow (current US$) in Rwanda?
Give a very brief answer. -4.40e+06. In the year 2004, what is the difference between the Aid flow (current US$) of Kyrgyz Republic and Aid flow (current US$) of Rwanda?
Offer a very short reply. -3.17e+06. In the year 2005, what is the difference between the Aid flow (current US$) of Least developed countries and Aid flow (current US$) of Honduras?
Provide a succinct answer. 7.08e+08. In the year 2005, what is the difference between the Aid flow (current US$) in Least developed countries and Aid flow (current US$) in Kyrgyz Republic?
Provide a succinct answer. 7.07e+08. In the year 2005, what is the difference between the Aid flow (current US$) of Least developed countries and Aid flow (current US$) of Rwanda?
Your answer should be compact. 7.06e+08. In the year 2005, what is the difference between the Aid flow (current US$) of Honduras and Aid flow (current US$) of Kyrgyz Republic?
Your answer should be compact. -1.39e+06. In the year 2005, what is the difference between the Aid flow (current US$) in Honduras and Aid flow (current US$) in Rwanda?
Your answer should be very brief. -2.81e+06. In the year 2005, what is the difference between the Aid flow (current US$) of Kyrgyz Republic and Aid flow (current US$) of Rwanda?
Offer a terse response. -1.42e+06. What is the ratio of the Aid flow (current US$) of Least developed countries in 1998 to that in 1999?
Give a very brief answer. 1.09. What is the ratio of the Aid flow (current US$) in Honduras in 1998 to that in 1999?
Make the answer very short. 1.26. What is the ratio of the Aid flow (current US$) of Kyrgyz Republic in 1998 to that in 1999?
Provide a succinct answer. 0.24. What is the ratio of the Aid flow (current US$) in Rwanda in 1998 to that in 1999?
Your answer should be very brief. 1.82. What is the ratio of the Aid flow (current US$) in Least developed countries in 1998 to that in 2000?
Provide a short and direct response. 1.17. What is the ratio of the Aid flow (current US$) of Honduras in 1998 to that in 2000?
Provide a short and direct response. 2.37. What is the ratio of the Aid flow (current US$) in Kyrgyz Republic in 1998 to that in 2000?
Ensure brevity in your answer.  1.03. What is the ratio of the Aid flow (current US$) in Rwanda in 1998 to that in 2000?
Your answer should be compact. 2.06. What is the ratio of the Aid flow (current US$) in Least developed countries in 1998 to that in 2001?
Keep it short and to the point. 1.15. What is the ratio of the Aid flow (current US$) of Honduras in 1998 to that in 2001?
Ensure brevity in your answer.  0.21. What is the ratio of the Aid flow (current US$) in Kyrgyz Republic in 1998 to that in 2001?
Provide a succinct answer. 0.59. What is the ratio of the Aid flow (current US$) in Rwanda in 1998 to that in 2001?
Ensure brevity in your answer.  4.33. What is the ratio of the Aid flow (current US$) in Least developed countries in 1998 to that in 2002?
Provide a short and direct response. 0.8. What is the ratio of the Aid flow (current US$) in Honduras in 1998 to that in 2002?
Keep it short and to the point. 5.3. What is the ratio of the Aid flow (current US$) of Kyrgyz Republic in 1998 to that in 2002?
Give a very brief answer. 0.23. What is the ratio of the Aid flow (current US$) in Rwanda in 1998 to that in 2002?
Offer a terse response. 1.45. What is the ratio of the Aid flow (current US$) of Least developed countries in 1998 to that in 2003?
Offer a very short reply. 0.63. What is the ratio of the Aid flow (current US$) of Honduras in 1998 to that in 2003?
Make the answer very short. 2.86. What is the ratio of the Aid flow (current US$) of Kyrgyz Republic in 1998 to that in 2003?
Provide a short and direct response. 0.1. What is the ratio of the Aid flow (current US$) in Rwanda in 1998 to that in 2003?
Offer a terse response. 1.1. What is the ratio of the Aid flow (current US$) in Least developed countries in 1998 to that in 2004?
Your response must be concise. 0.59. What is the ratio of the Aid flow (current US$) of Honduras in 1998 to that in 2004?
Give a very brief answer. 2.53. What is the ratio of the Aid flow (current US$) of Kyrgyz Republic in 1998 to that in 2004?
Make the answer very short. 0.1. What is the ratio of the Aid flow (current US$) in Rwanda in 1998 to that in 2004?
Offer a very short reply. 1.41. What is the ratio of the Aid flow (current US$) in Least developed countries in 1998 to that in 2005?
Offer a terse response. 0.51. What is the ratio of the Aid flow (current US$) in Honduras in 1998 to that in 2005?
Your answer should be compact. 2.76. What is the ratio of the Aid flow (current US$) of Kyrgyz Republic in 1998 to that in 2005?
Keep it short and to the point. 0.1. What is the ratio of the Aid flow (current US$) of Rwanda in 1998 to that in 2005?
Give a very brief answer. 1.96. What is the ratio of the Aid flow (current US$) in Least developed countries in 1999 to that in 2000?
Offer a very short reply. 1.07. What is the ratio of the Aid flow (current US$) in Honduras in 1999 to that in 2000?
Keep it short and to the point. 1.88. What is the ratio of the Aid flow (current US$) of Kyrgyz Republic in 1999 to that in 2000?
Offer a very short reply. 4.24. What is the ratio of the Aid flow (current US$) of Rwanda in 1999 to that in 2000?
Provide a succinct answer. 1.13. What is the ratio of the Aid flow (current US$) of Least developed countries in 1999 to that in 2001?
Your response must be concise. 1.06. What is the ratio of the Aid flow (current US$) of Honduras in 1999 to that in 2001?
Keep it short and to the point. 0.17. What is the ratio of the Aid flow (current US$) in Kyrgyz Republic in 1999 to that in 2001?
Your response must be concise. 2.41. What is the ratio of the Aid flow (current US$) of Rwanda in 1999 to that in 2001?
Keep it short and to the point. 2.38. What is the ratio of the Aid flow (current US$) of Least developed countries in 1999 to that in 2002?
Your answer should be very brief. 0.74. What is the ratio of the Aid flow (current US$) in Honduras in 1999 to that in 2002?
Offer a very short reply. 4.2. What is the ratio of the Aid flow (current US$) in Kyrgyz Republic in 1999 to that in 2002?
Your response must be concise. 0.94. What is the ratio of the Aid flow (current US$) of Rwanda in 1999 to that in 2002?
Ensure brevity in your answer.  0.79. What is the ratio of the Aid flow (current US$) of Least developed countries in 1999 to that in 2003?
Provide a short and direct response. 0.58. What is the ratio of the Aid flow (current US$) in Honduras in 1999 to that in 2003?
Your answer should be very brief. 2.27. What is the ratio of the Aid flow (current US$) of Kyrgyz Republic in 1999 to that in 2003?
Offer a terse response. 0.4. What is the ratio of the Aid flow (current US$) in Rwanda in 1999 to that in 2003?
Your answer should be compact. 0.61. What is the ratio of the Aid flow (current US$) of Least developed countries in 1999 to that in 2004?
Offer a very short reply. 0.54. What is the ratio of the Aid flow (current US$) in Honduras in 1999 to that in 2004?
Your answer should be very brief. 2.01. What is the ratio of the Aid flow (current US$) in Kyrgyz Republic in 1999 to that in 2004?
Keep it short and to the point. 0.4. What is the ratio of the Aid flow (current US$) of Rwanda in 1999 to that in 2004?
Keep it short and to the point. 0.78. What is the ratio of the Aid flow (current US$) in Least developed countries in 1999 to that in 2005?
Provide a succinct answer. 0.47. What is the ratio of the Aid flow (current US$) in Honduras in 1999 to that in 2005?
Provide a short and direct response. 2.19. What is the ratio of the Aid flow (current US$) of Kyrgyz Republic in 1999 to that in 2005?
Provide a short and direct response. 0.4. What is the ratio of the Aid flow (current US$) of Rwanda in 1999 to that in 2005?
Provide a succinct answer. 1.08. What is the ratio of the Aid flow (current US$) in Least developed countries in 2000 to that in 2001?
Your answer should be compact. 0.99. What is the ratio of the Aid flow (current US$) of Honduras in 2000 to that in 2001?
Provide a succinct answer. 0.09. What is the ratio of the Aid flow (current US$) of Kyrgyz Republic in 2000 to that in 2001?
Offer a very short reply. 0.57. What is the ratio of the Aid flow (current US$) in Rwanda in 2000 to that in 2001?
Your answer should be compact. 2.1. What is the ratio of the Aid flow (current US$) in Least developed countries in 2000 to that in 2002?
Your answer should be very brief. 0.69. What is the ratio of the Aid flow (current US$) of Honduras in 2000 to that in 2002?
Give a very brief answer. 2.24. What is the ratio of the Aid flow (current US$) in Kyrgyz Republic in 2000 to that in 2002?
Keep it short and to the point. 0.22. What is the ratio of the Aid flow (current US$) in Rwanda in 2000 to that in 2002?
Provide a short and direct response. 0.7. What is the ratio of the Aid flow (current US$) of Least developed countries in 2000 to that in 2003?
Your response must be concise. 0.54. What is the ratio of the Aid flow (current US$) in Honduras in 2000 to that in 2003?
Make the answer very short. 1.21. What is the ratio of the Aid flow (current US$) of Kyrgyz Republic in 2000 to that in 2003?
Provide a short and direct response. 0.09. What is the ratio of the Aid flow (current US$) in Rwanda in 2000 to that in 2003?
Ensure brevity in your answer.  0.54. What is the ratio of the Aid flow (current US$) of Least developed countries in 2000 to that in 2004?
Offer a terse response. 0.5. What is the ratio of the Aid flow (current US$) of Honduras in 2000 to that in 2004?
Provide a succinct answer. 1.07. What is the ratio of the Aid flow (current US$) of Kyrgyz Republic in 2000 to that in 2004?
Provide a short and direct response. 0.09. What is the ratio of the Aid flow (current US$) of Rwanda in 2000 to that in 2004?
Keep it short and to the point. 0.68. What is the ratio of the Aid flow (current US$) of Least developed countries in 2000 to that in 2005?
Provide a succinct answer. 0.44. What is the ratio of the Aid flow (current US$) of Honduras in 2000 to that in 2005?
Your response must be concise. 1.17. What is the ratio of the Aid flow (current US$) in Kyrgyz Republic in 2000 to that in 2005?
Your response must be concise. 0.09. What is the ratio of the Aid flow (current US$) in Rwanda in 2000 to that in 2005?
Provide a succinct answer. 0.95. What is the ratio of the Aid flow (current US$) in Least developed countries in 2001 to that in 2002?
Keep it short and to the point. 0.7. What is the ratio of the Aid flow (current US$) of Honduras in 2001 to that in 2002?
Your answer should be compact. 24.81. What is the ratio of the Aid flow (current US$) of Kyrgyz Republic in 2001 to that in 2002?
Give a very brief answer. 0.39. What is the ratio of the Aid flow (current US$) of Rwanda in 2001 to that in 2002?
Your answer should be very brief. 0.33. What is the ratio of the Aid flow (current US$) of Least developed countries in 2001 to that in 2003?
Your answer should be very brief. 0.55. What is the ratio of the Aid flow (current US$) in Honduras in 2001 to that in 2003?
Offer a terse response. 13.39. What is the ratio of the Aid flow (current US$) in Kyrgyz Republic in 2001 to that in 2003?
Keep it short and to the point. 0.17. What is the ratio of the Aid flow (current US$) in Rwanda in 2001 to that in 2003?
Ensure brevity in your answer.  0.25. What is the ratio of the Aid flow (current US$) of Least developed countries in 2001 to that in 2004?
Your response must be concise. 0.51. What is the ratio of the Aid flow (current US$) in Honduras in 2001 to that in 2004?
Provide a succinct answer. 11.86. What is the ratio of the Aid flow (current US$) of Kyrgyz Republic in 2001 to that in 2004?
Ensure brevity in your answer.  0.17. What is the ratio of the Aid flow (current US$) of Rwanda in 2001 to that in 2004?
Offer a very short reply. 0.33. What is the ratio of the Aid flow (current US$) of Least developed countries in 2001 to that in 2005?
Make the answer very short. 0.44. What is the ratio of the Aid flow (current US$) of Honduras in 2001 to that in 2005?
Ensure brevity in your answer.  12.92. What is the ratio of the Aid flow (current US$) of Kyrgyz Republic in 2001 to that in 2005?
Your response must be concise. 0.17. What is the ratio of the Aid flow (current US$) in Rwanda in 2001 to that in 2005?
Offer a very short reply. 0.45. What is the ratio of the Aid flow (current US$) of Least developed countries in 2002 to that in 2003?
Give a very brief answer. 0.78. What is the ratio of the Aid flow (current US$) of Honduras in 2002 to that in 2003?
Give a very brief answer. 0.54. What is the ratio of the Aid flow (current US$) in Kyrgyz Republic in 2002 to that in 2003?
Offer a very short reply. 0.43. What is the ratio of the Aid flow (current US$) of Rwanda in 2002 to that in 2003?
Keep it short and to the point. 0.76. What is the ratio of the Aid flow (current US$) in Least developed countries in 2002 to that in 2004?
Keep it short and to the point. 0.73. What is the ratio of the Aid flow (current US$) in Honduras in 2002 to that in 2004?
Ensure brevity in your answer.  0.48. What is the ratio of the Aid flow (current US$) of Kyrgyz Republic in 2002 to that in 2004?
Make the answer very short. 0.43. What is the ratio of the Aid flow (current US$) of Least developed countries in 2002 to that in 2005?
Provide a short and direct response. 0.63. What is the ratio of the Aid flow (current US$) in Honduras in 2002 to that in 2005?
Provide a short and direct response. 0.52. What is the ratio of the Aid flow (current US$) in Kyrgyz Republic in 2002 to that in 2005?
Make the answer very short. 0.43. What is the ratio of the Aid flow (current US$) of Rwanda in 2002 to that in 2005?
Your answer should be compact. 1.35. What is the ratio of the Aid flow (current US$) of Least developed countries in 2003 to that in 2004?
Ensure brevity in your answer.  0.94. What is the ratio of the Aid flow (current US$) in Honduras in 2003 to that in 2004?
Provide a short and direct response. 0.89. What is the ratio of the Aid flow (current US$) of Kyrgyz Republic in 2003 to that in 2004?
Your answer should be very brief. 1. What is the ratio of the Aid flow (current US$) in Rwanda in 2003 to that in 2004?
Make the answer very short. 1.28. What is the ratio of the Aid flow (current US$) in Least developed countries in 2003 to that in 2005?
Make the answer very short. 0.81. What is the ratio of the Aid flow (current US$) of Honduras in 2003 to that in 2005?
Your answer should be compact. 0.96. What is the ratio of the Aid flow (current US$) in Kyrgyz Republic in 2003 to that in 2005?
Ensure brevity in your answer.  1. What is the ratio of the Aid flow (current US$) in Rwanda in 2003 to that in 2005?
Keep it short and to the point. 1.77. What is the ratio of the Aid flow (current US$) of Least developed countries in 2004 to that in 2005?
Ensure brevity in your answer.  0.87. What is the ratio of the Aid flow (current US$) of Honduras in 2004 to that in 2005?
Provide a short and direct response. 1.09. What is the ratio of the Aid flow (current US$) of Kyrgyz Republic in 2004 to that in 2005?
Ensure brevity in your answer.  1. What is the ratio of the Aid flow (current US$) of Rwanda in 2004 to that in 2005?
Keep it short and to the point. 1.39. What is the difference between the highest and the second highest Aid flow (current US$) in Least developed countries?
Ensure brevity in your answer.  9.29e+07. What is the difference between the highest and the second highest Aid flow (current US$) of Honduras?
Ensure brevity in your answer.  1.72e+07. What is the difference between the highest and the second highest Aid flow (current US$) in Kyrgyz Republic?
Provide a short and direct response. 10000. What is the difference between the highest and the second highest Aid flow (current US$) in Rwanda?
Offer a terse response. 8.30e+05. What is the difference between the highest and the lowest Aid flow (current US$) of Least developed countries?
Offer a terse response. 3.99e+08. What is the difference between the highest and the lowest Aid flow (current US$) in Honduras?
Your answer should be compact. 2.10e+07. What is the difference between the highest and the lowest Aid flow (current US$) of Kyrgyz Republic?
Offer a very short reply. 2.79e+06. What is the difference between the highest and the lowest Aid flow (current US$) of Rwanda?
Offer a very short reply. 6.77e+06. 